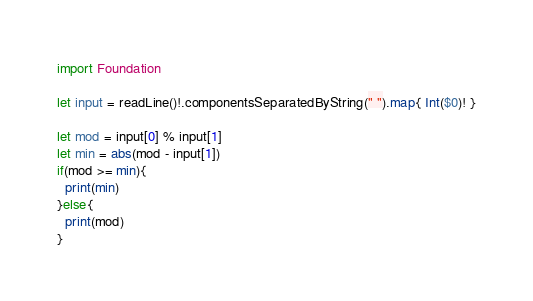<code> <loc_0><loc_0><loc_500><loc_500><_Swift_>import Foundation

let input = readLine()!.componentsSeparatedByString(" ").map{ Int($0)! }

let mod = input[0] % input[1]
let min = abs(mod - input[1])
if(mod >= min){
  print(min)
}else{
  print(mod)
}</code> 